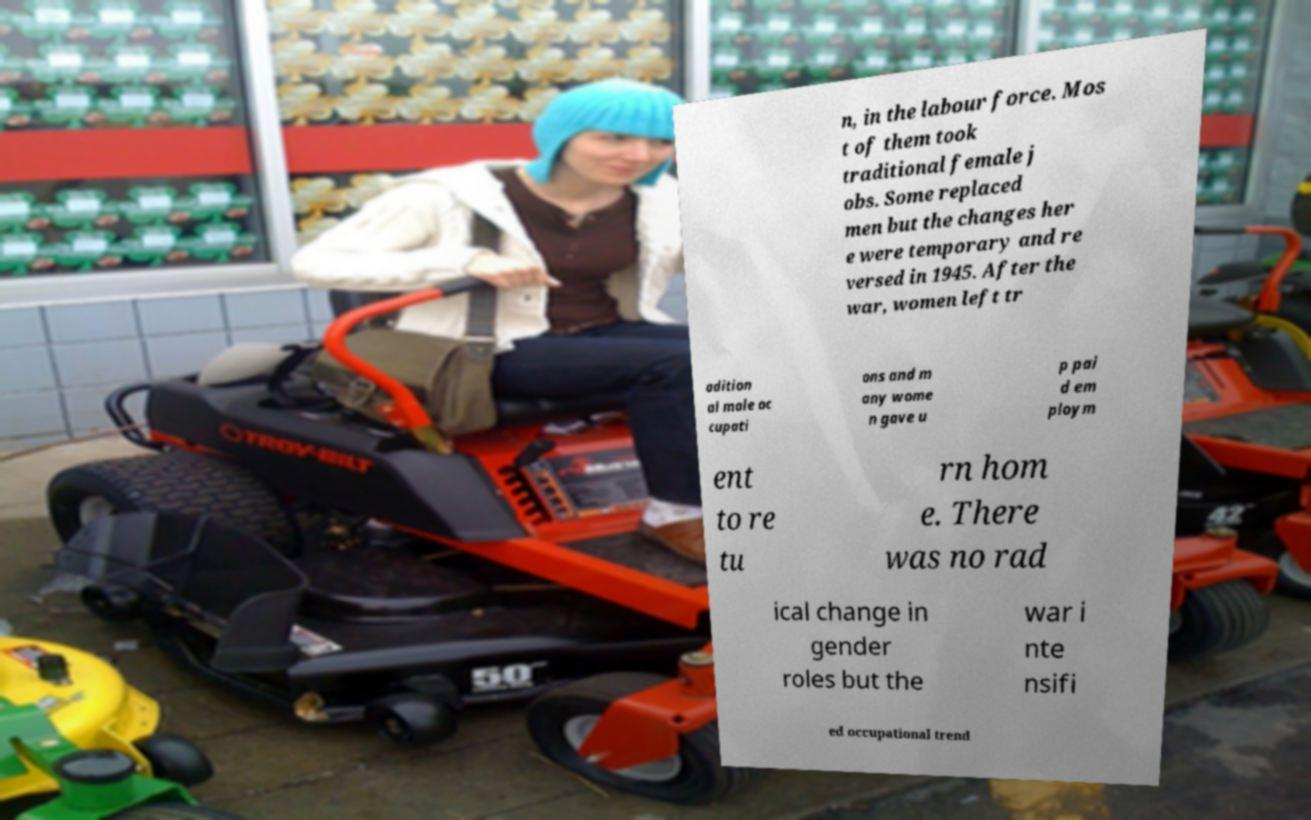Can you read and provide the text displayed in the image?This photo seems to have some interesting text. Can you extract and type it out for me? n, in the labour force. Mos t of them took traditional female j obs. Some replaced men but the changes her e were temporary and re versed in 1945. After the war, women left tr adition al male oc cupati ons and m any wome n gave u p pai d em ploym ent to re tu rn hom e. There was no rad ical change in gender roles but the war i nte nsifi ed occupational trend 